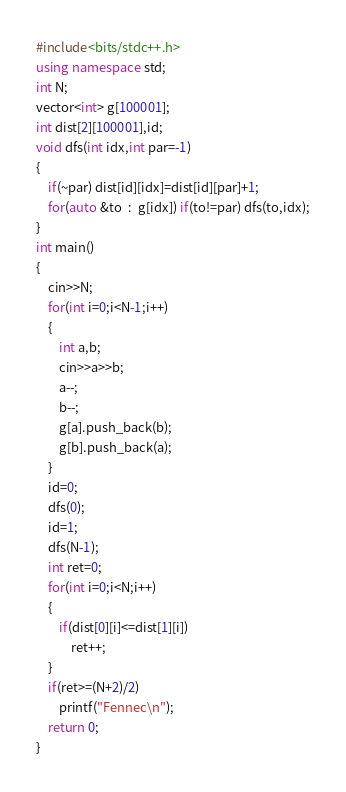<code> <loc_0><loc_0><loc_500><loc_500><_C++_>#include<bits/stdc++.h> 
using namespace std;
int N;
vector<int> g[100001];
int dist[2][100001],id;
void dfs(int idx,int par=-1)
{
	if(~par) dist[id][idx]=dist[id][par]+1;
	for(auto &to  :  g[idx]) if(to!=par) dfs(to,idx);
} 
int main()
{
	cin>>N;
	for(int i=0;i<N-1;i++)
	{
		int a,b;
		cin>>a>>b;
		a--;
		b--;
		g[a].push_back(b);
		g[b].push_back(a);
	}
	id=0;
	dfs(0);
	id=1;
	dfs(N-1);
	int ret=0;
	for(int i=0;i<N;i++)
	{
		if(dist[0][i]<=dist[1][i])
			ret++;
	}
	if(ret>=(N+2)/2)
	    printf("Fennec\n");
	return 0;
}</code> 